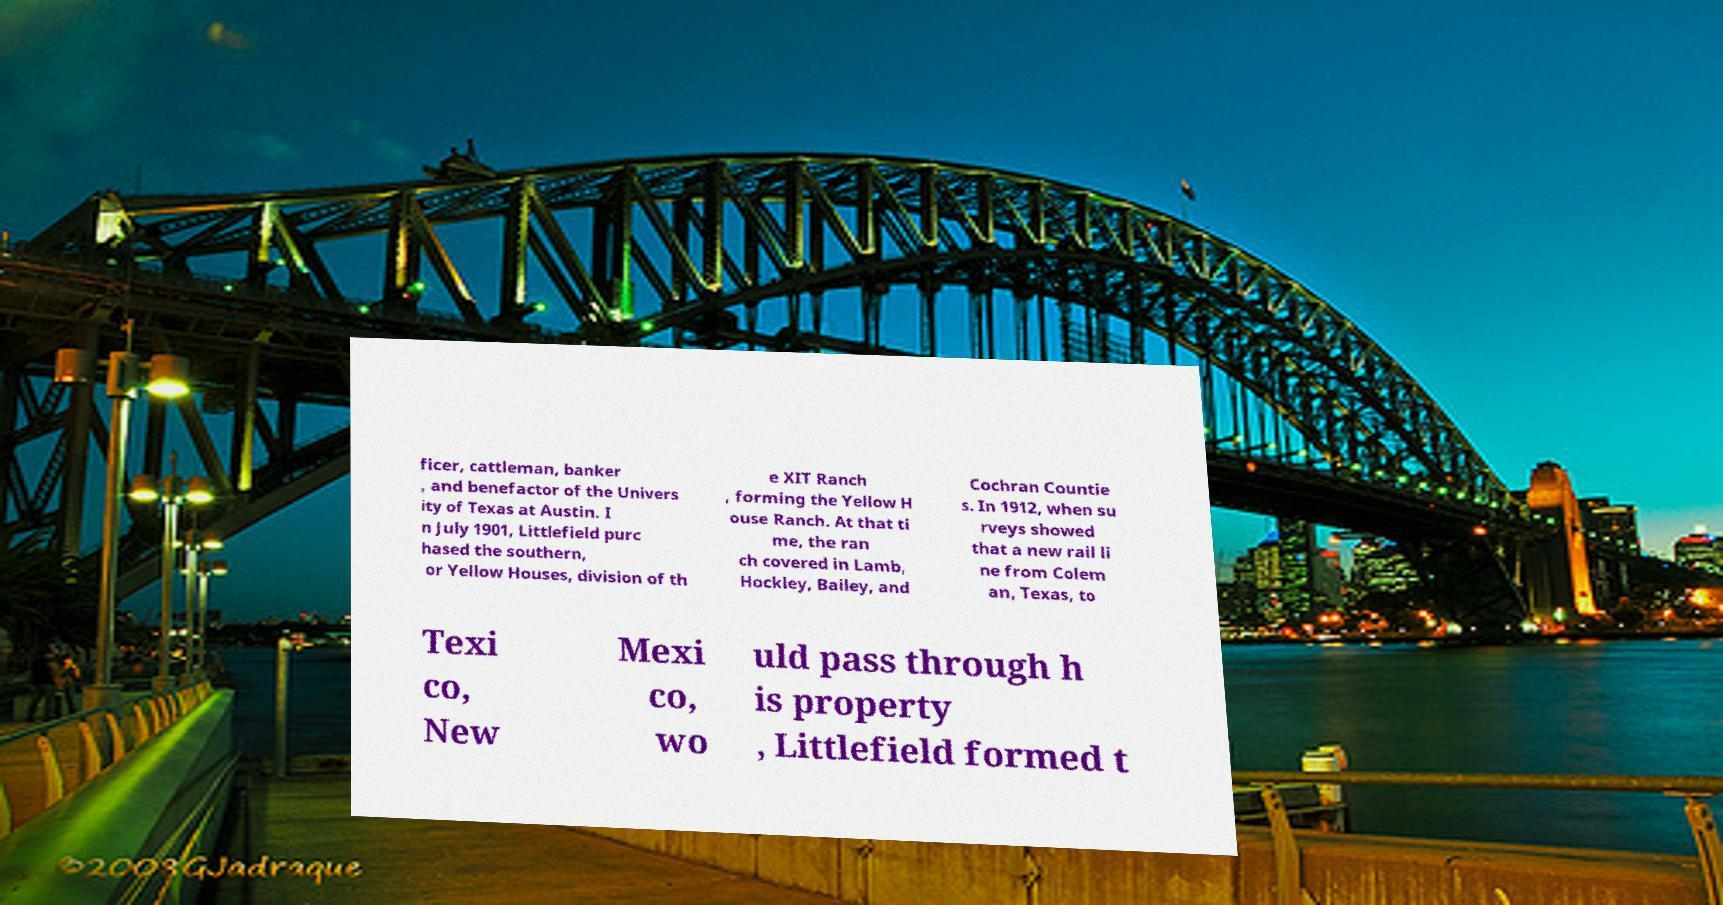Please read and relay the text visible in this image. What does it say? ficer, cattleman, banker , and benefactor of the Univers ity of Texas at Austin. I n July 1901, Littlefield purc hased the southern, or Yellow Houses, division of th e XIT Ranch , forming the Yellow H ouse Ranch. At that ti me, the ran ch covered in Lamb, Hockley, Bailey, and Cochran Countie s. In 1912, when su rveys showed that a new rail li ne from Colem an, Texas, to Texi co, New Mexi co, wo uld pass through h is property , Littlefield formed t 